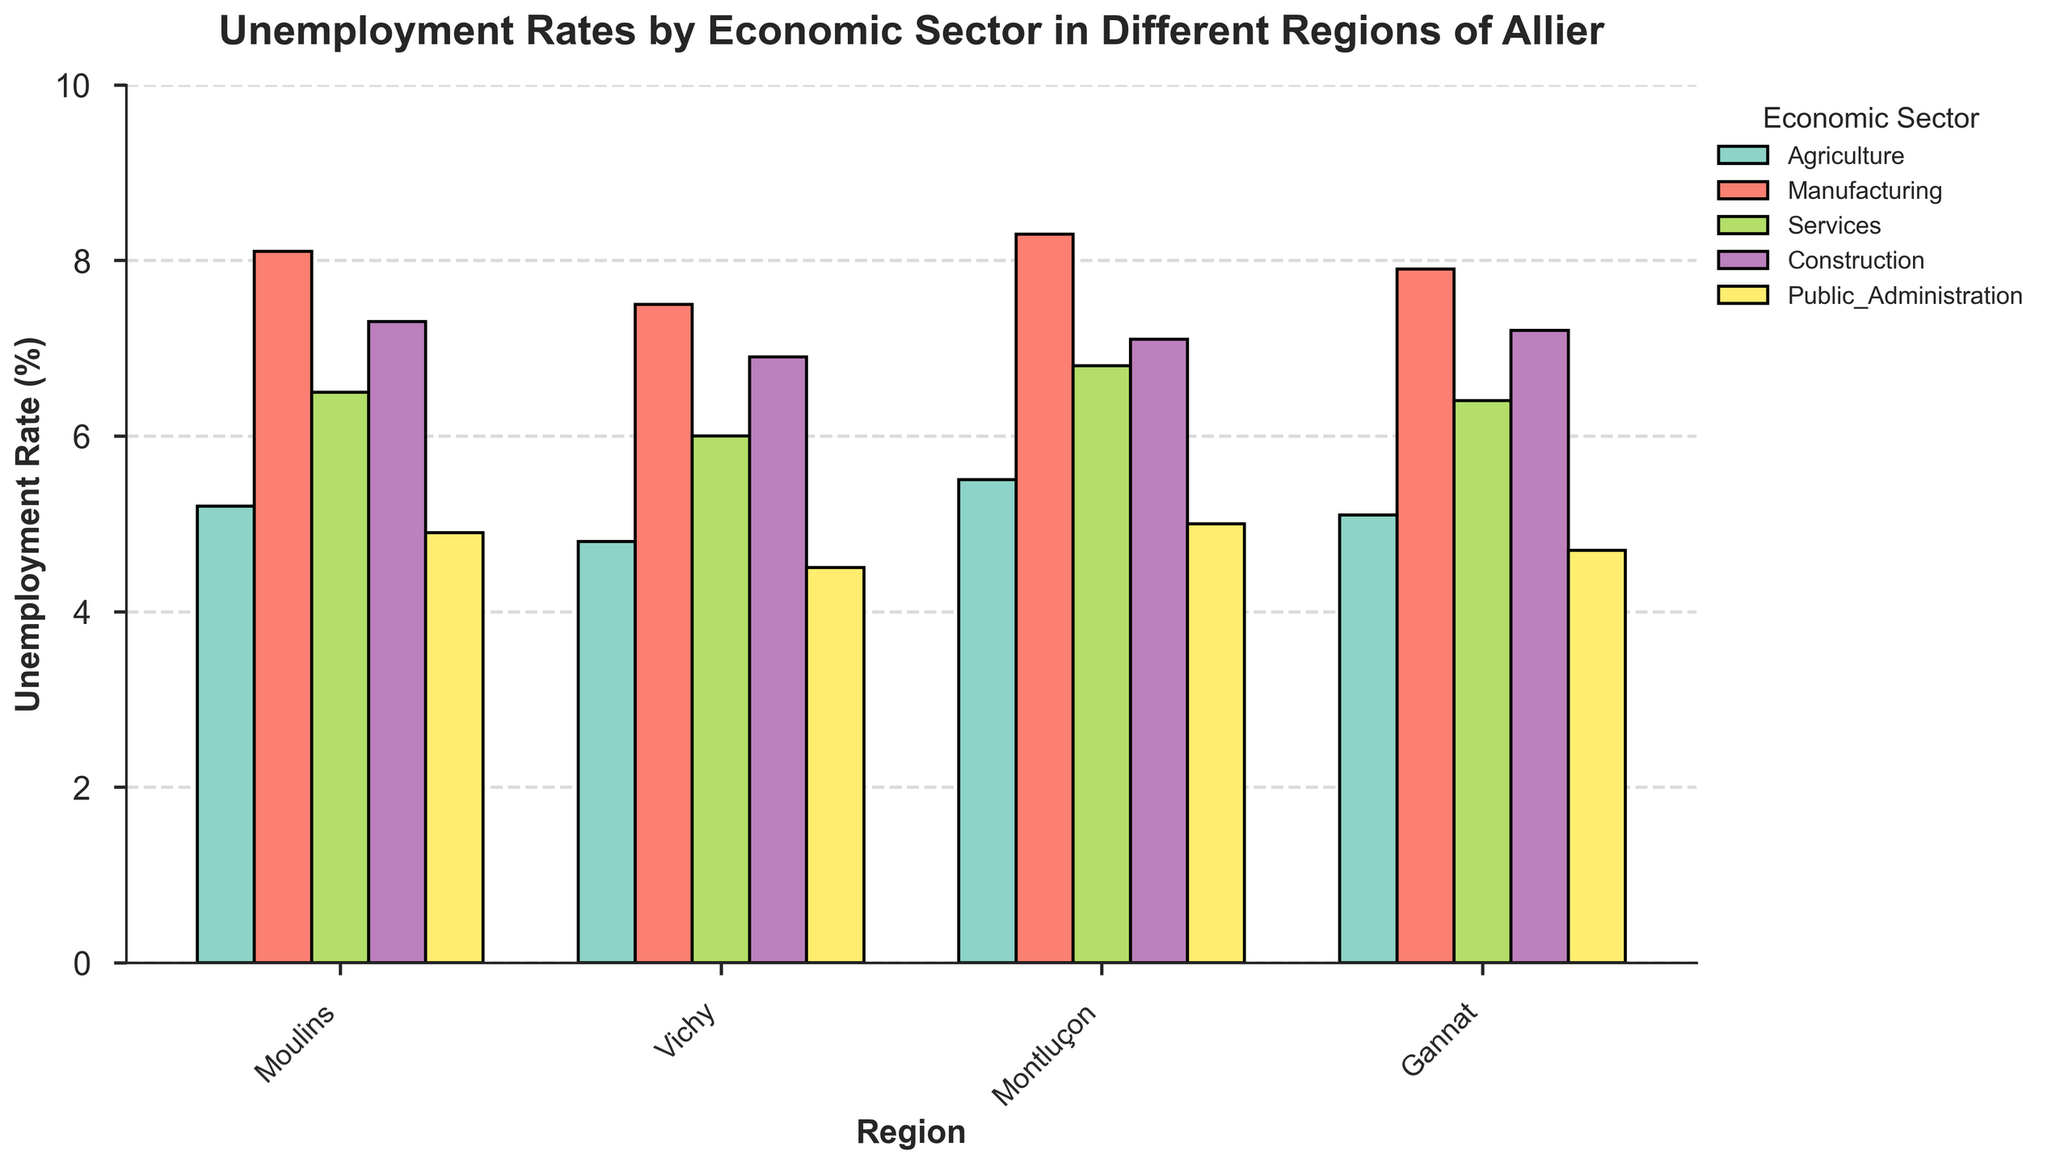What's the economic sector with the highest unemployment rate in Moulins? Look at the bars in Moulins, and identify the tallest; the sector label of this bar indicates the highest unemployment rate.
Answer: Manufacturing What's the overall trend of unemployment rates in Public Administration across all regions? Examine the heights of all bars labeled as Public Administration in all regions. Identify if they are generally low or high compared to others.
Answer: Generally low How does the unemployment rate in Agriculture in Vichy compare to Moulins? Compare the heights of the Agriculture bars in Vichy and Moulins. If Vichy's bar is shorter, it has a lower rate; if taller, a higher rate.
Answer: Lower Which region has the lowest unemployment rate in Services? Look at the Services bars across all regions and identify the shortest one. The corresponding region is the answer.
Answer: Vichy What's the average unemployment rate for Manufacturing across all regions? Add the values of the Manufacturing bars for all regions and divide by the number of regions to find the average.
Answer: 7.95 In which region is the unemployment rate in Construction the highest? Identify the tallest Construction bar and note the corresponding region.
Answer: Moulins How does the unemployment rate in Agriculture in Gannat compare to Montluçon? Compare the heights of the Agriculture bars in Gannat and Montluçon. Determine if Gannat's bar is taller, shorter, or the same.
Answer: Lower Which region has the most balanced (closest together) unemployment rates across all economic sectors? Examine the range of bar heights within each region and identify which region's bars have the least variation in height from one another.
Answer: Vichy What's the largest gap between the highest and lowest unemployment rates within a single region? Calculate the difference between the tallest and shortest bars within each region and identify the largest difference.
Answer: 3.2 (Montluçon, 8.3 - 5.1) What is the unemployment rate for Construction in Montluçon? Locate the Construction bar in Montluçon and note its height.
Answer: 7.1 